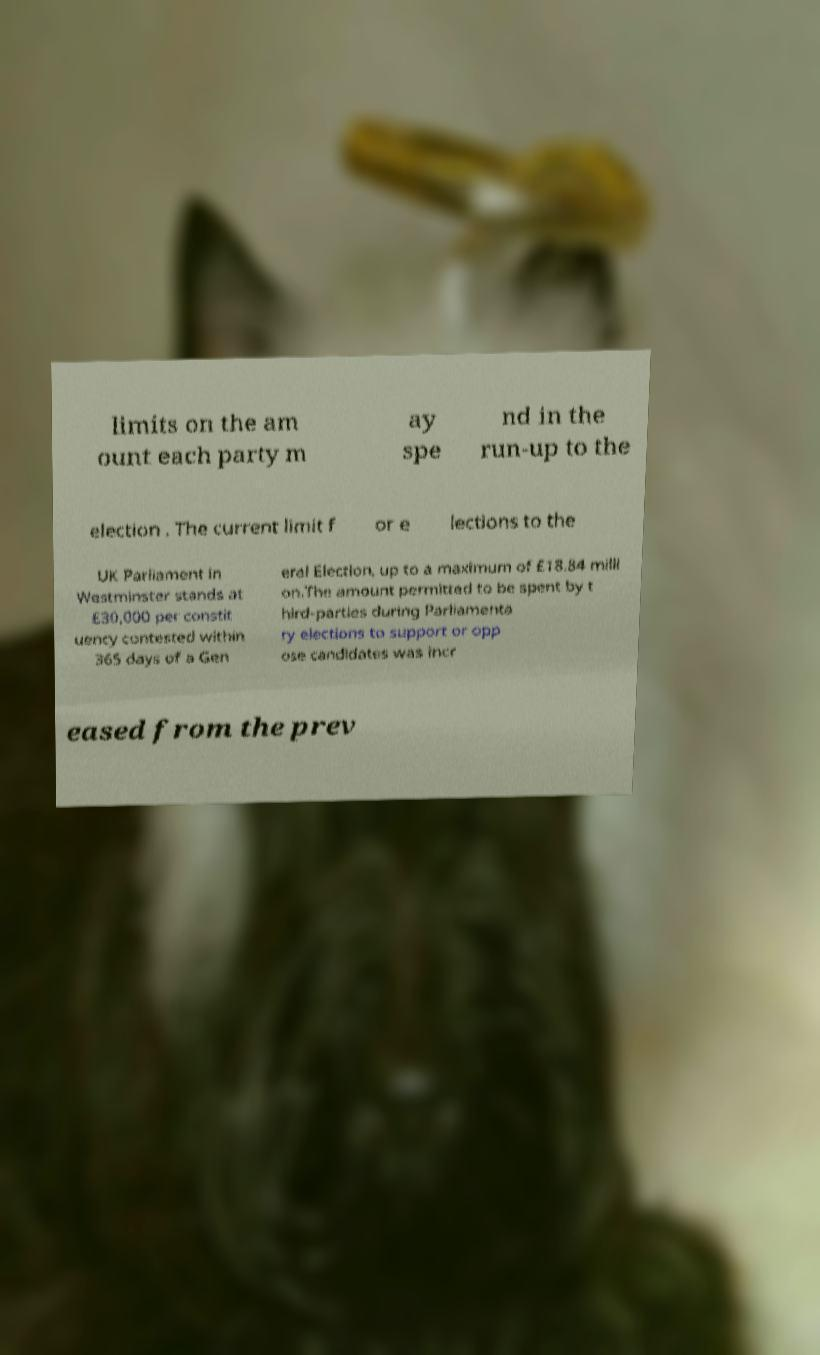Please read and relay the text visible in this image. What does it say? limits on the am ount each party m ay spe nd in the run-up to the election . The current limit f or e lections to the UK Parliament in Westminster stands at £30,000 per constit uency contested within 365 days of a Gen eral Election, up to a maximum of £18.84 milli on.The amount permitted to be spent by t hird-parties during Parliamenta ry elections to support or opp ose candidates was incr eased from the prev 